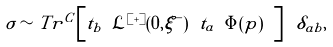Convert formula to latex. <formula><loc_0><loc_0><loc_500><loc_500>\sigma \sim T r ^ { C } \left [ t _ { b } \ \mathcal { L } ^ { [ + ] } ( 0 , \xi ^ { - } ) \ t _ { a } \ \Phi ( p ) \ \right ] \ \delta _ { a b } ,</formula> 